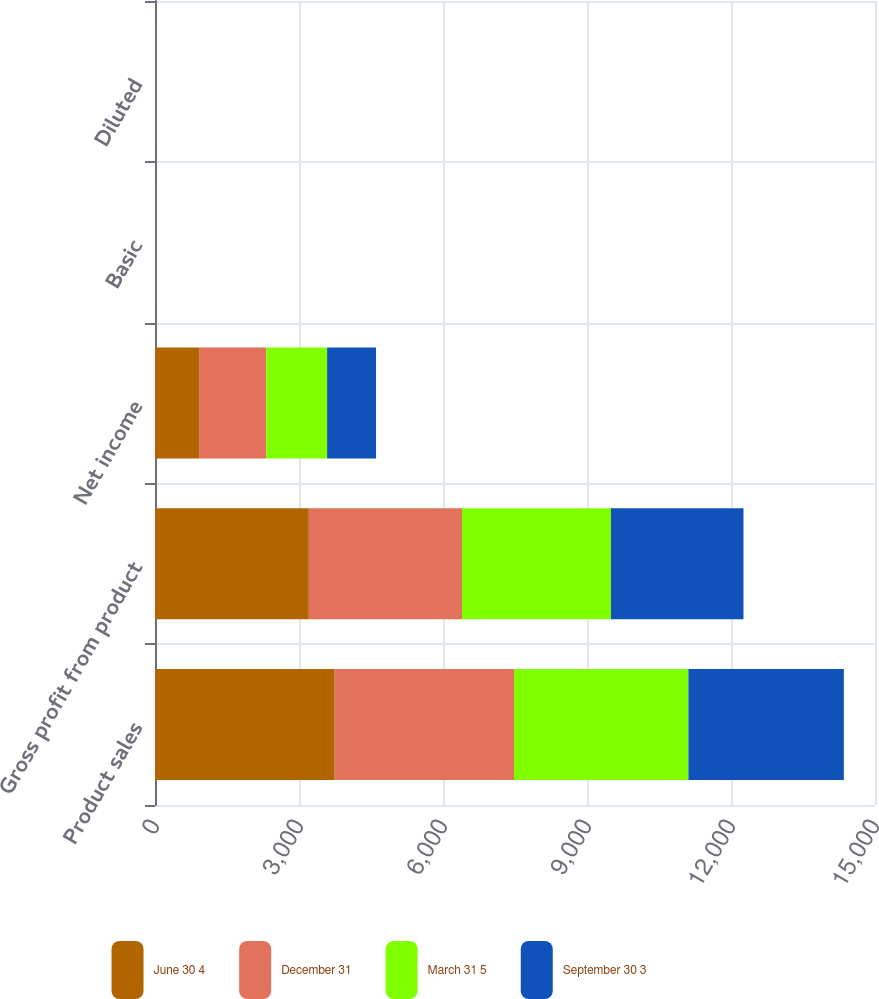Convert chart. <chart><loc_0><loc_0><loc_500><loc_500><stacked_bar_chart><ecel><fcel>Product sales<fcel>Gross profit from product<fcel>Net income<fcel>Basic<fcel>Diluted<nl><fcel>June 30 4<fcel>3743<fcel>3205<fcel>931<fcel>0.93<fcel>0.92<nl><fcel>December 31<fcel>3736<fcel>3191<fcel>1386<fcel>1.36<fcel>1.36<nl><fcel>March 31 5<fcel>3634<fcel>3103<fcel>1269<fcel>1.25<fcel>1.25<nl><fcel>September 30 3<fcel>3238<fcel>2761<fcel>1019<fcel>0.99<fcel>0.98<nl></chart> 